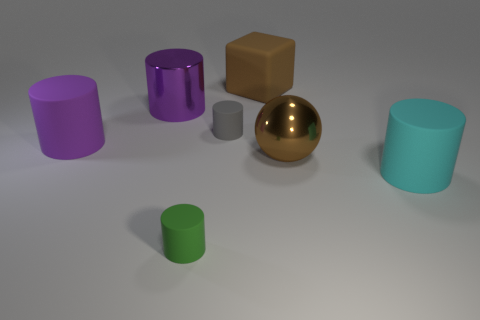Subtract all purple metal cylinders. How many cylinders are left? 4 Add 2 purple metal cylinders. How many objects exist? 9 Subtract all cyan cylinders. How many cylinders are left? 4 Subtract all balls. How many objects are left? 6 Subtract all purple spheres. How many purple cylinders are left? 2 Subtract all metal things. Subtract all big brown rubber objects. How many objects are left? 4 Add 2 big brown metal spheres. How many big brown metal spheres are left? 3 Add 7 shiny things. How many shiny things exist? 9 Subtract 1 brown blocks. How many objects are left? 6 Subtract all gray cylinders. Subtract all green spheres. How many cylinders are left? 4 